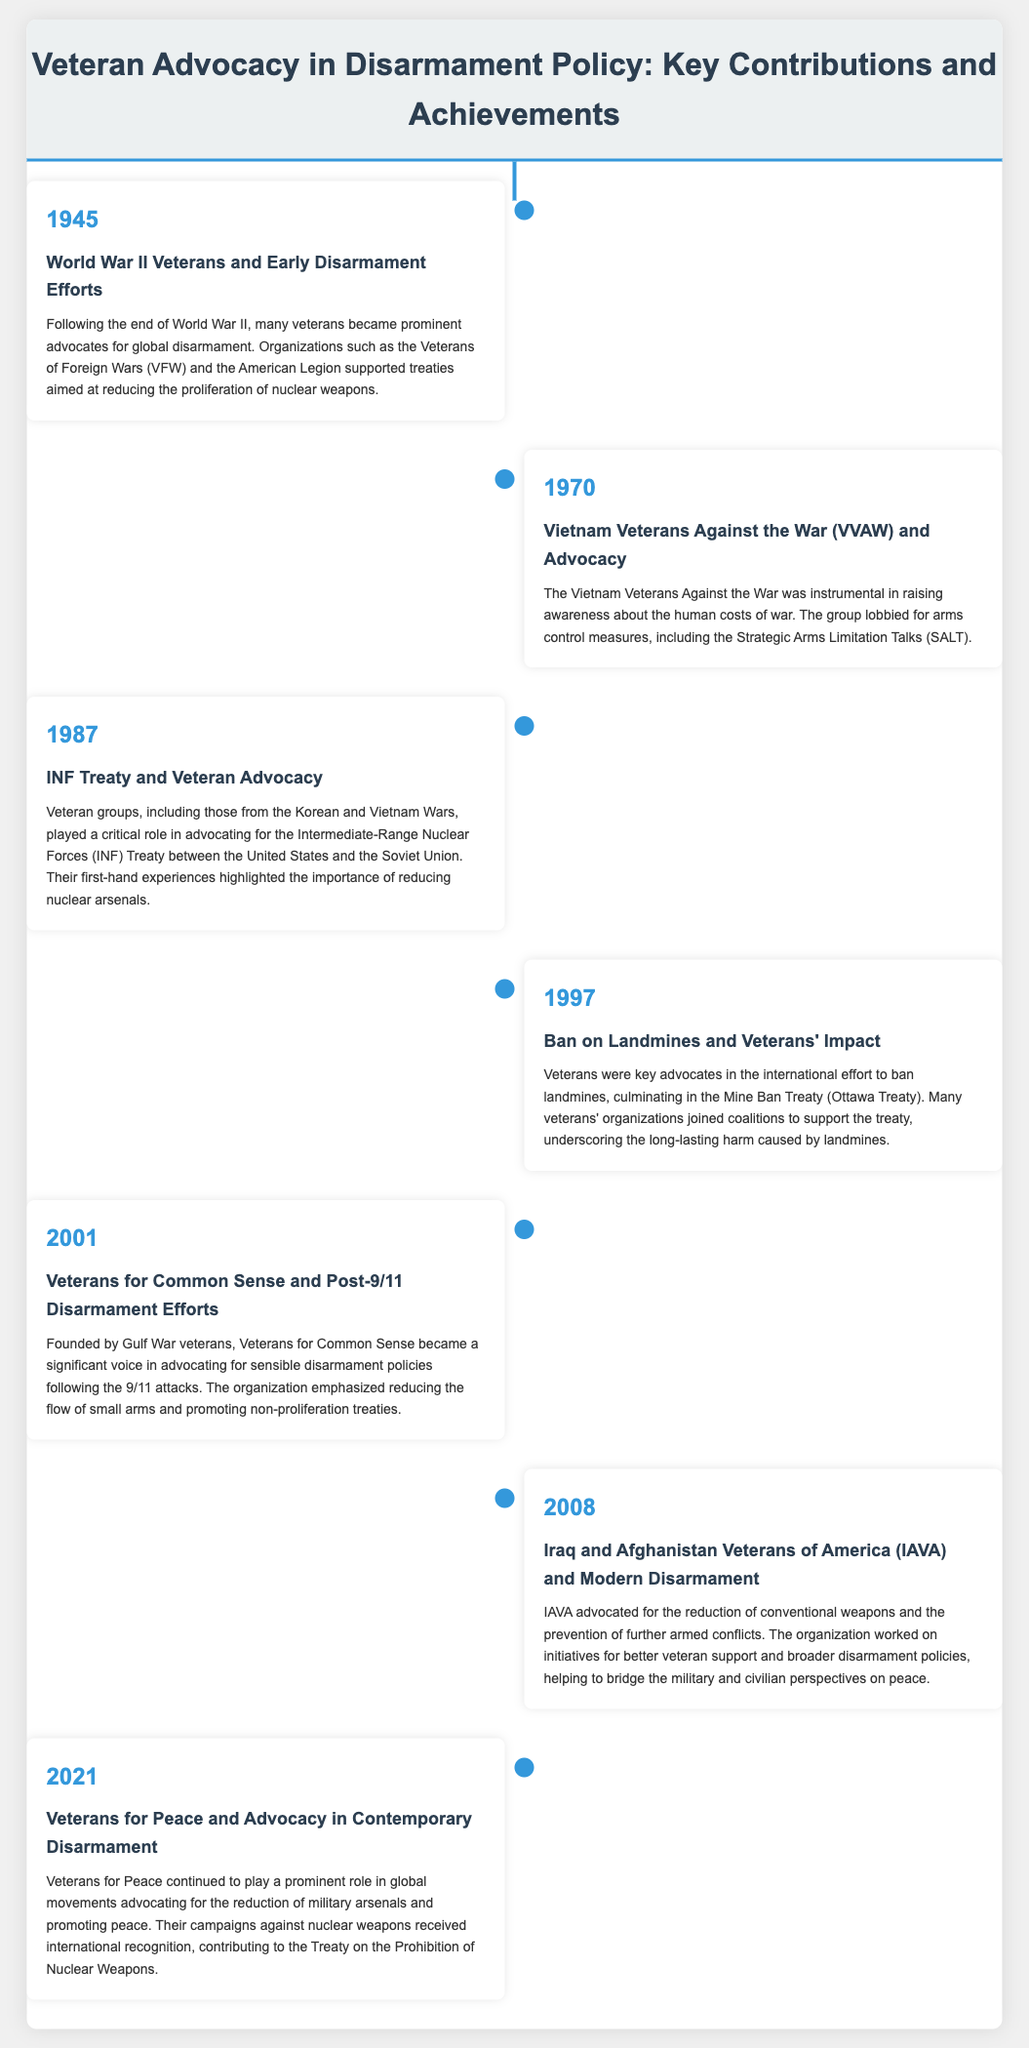What year did World War II veterans start advocating for disarmament? The document states that World War II veterans began advocating for disarmament following the end of World War II in 1945.
Answer: 1945 Which organization was prominent among the Vietnam Veterans Against the War? The document highlights that the Vietnam Veterans Against the War (VVAW) was influential in arms control measures in 1970.
Answer: VVAW What treaty did veterans advocate for in 1987? According to the document, veteran groups advocated for the Intermediate-Range Nuclear Forces (INF) Treaty in 1987.
Answer: INF Treaty What significant international agreement did veterans help support regarding landmines in 1997? The document mentions that veterans were key advocates for the Mine Ban Treaty (Ottawa Treaty) in 1997.
Answer: Mine Ban Treaty Which organization was founded by Gulf War veterans in 2001? The document indicates that Veterans for Common Sense was founded by Gulf War veterans in 2001.
Answer: Veterans for Common Sense How did the advocacy efforts change post-9/11 according to the document? The document states that post-9/11, Veterans for Common Sense focused on reducing the flow of small arms and promoting non-proliferation treaties.
Answer: Reducing small arms What role did IAVA play in disarmament advocacy in 2008? The document notes that IAVA advocated for the reduction of conventional weapons and better veteran support in 2008.
Answer: Reduction of conventional weapons What year did Veterans for Peace contribute to the Treaty on the Prohibition of Nuclear Weapons? The document indicates that Veterans for Peace contributed to nuclear disarmament in 2021.
Answer: 2021 Which event marked a significant change in veteran advocacy for peace? The timeline shows that the advocacy efforts by Veterans for Peace in 2021 were a notable contribution to contemporary disarmament.
Answer: Veterans for Peace in 2021 